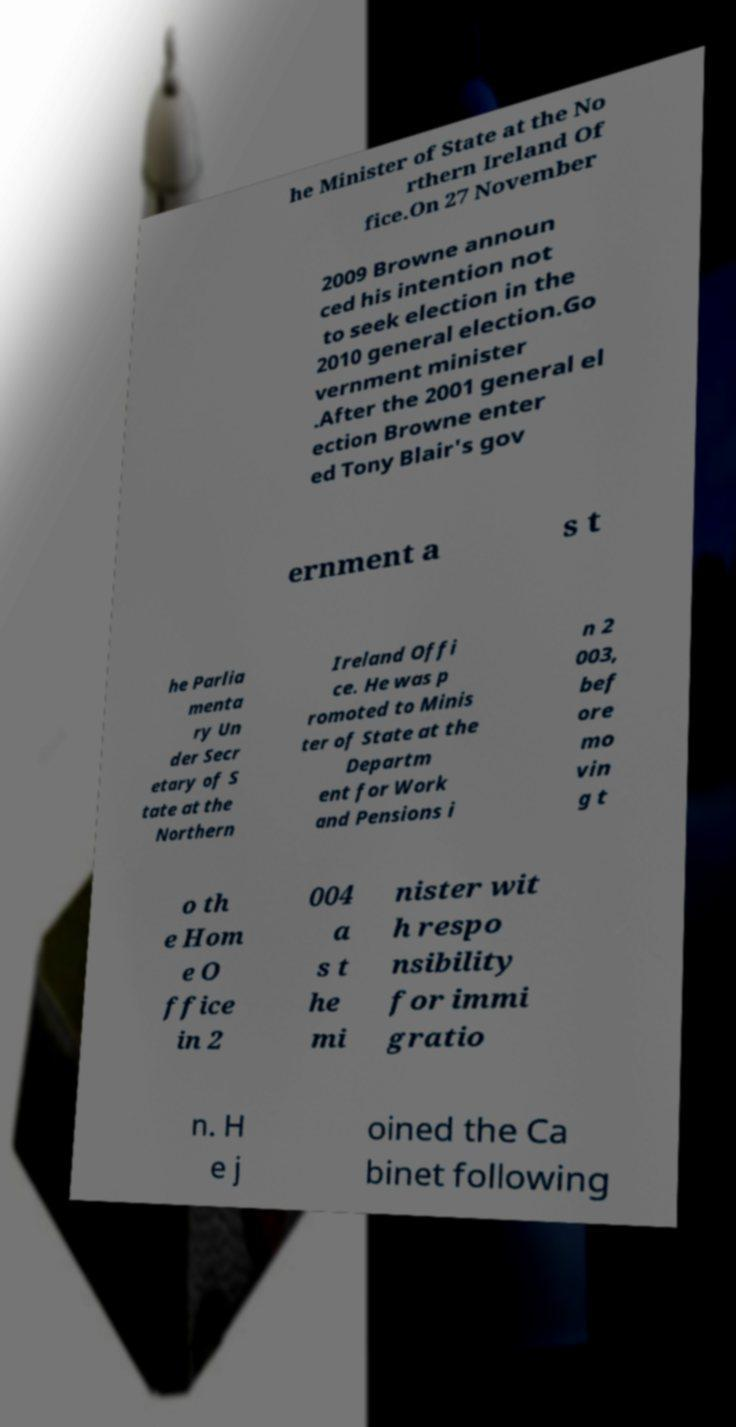Please read and relay the text visible in this image. What does it say? he Minister of State at the No rthern Ireland Of fice.On 27 November 2009 Browne announ ced his intention not to seek election in the 2010 general election.Go vernment minister .After the 2001 general el ection Browne enter ed Tony Blair's gov ernment a s t he Parlia menta ry Un der Secr etary of S tate at the Northern Ireland Offi ce. He was p romoted to Minis ter of State at the Departm ent for Work and Pensions i n 2 003, bef ore mo vin g t o th e Hom e O ffice in 2 004 a s t he mi nister wit h respo nsibility for immi gratio n. H e j oined the Ca binet following 